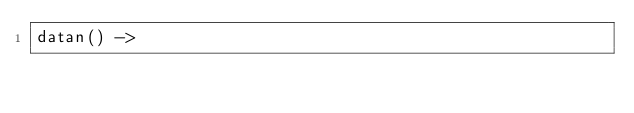Convert code to text. <code><loc_0><loc_0><loc_500><loc_500><_Erlang_>datan() -></code> 